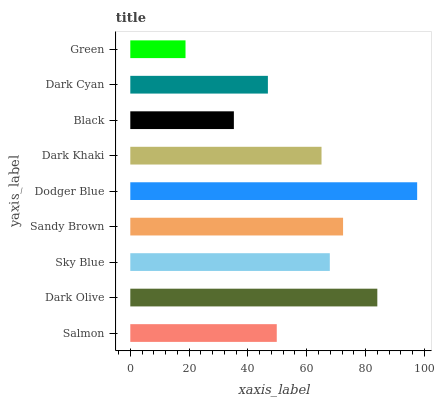Is Green the minimum?
Answer yes or no. Yes. Is Dodger Blue the maximum?
Answer yes or no. Yes. Is Dark Olive the minimum?
Answer yes or no. No. Is Dark Olive the maximum?
Answer yes or no. No. Is Dark Olive greater than Salmon?
Answer yes or no. Yes. Is Salmon less than Dark Olive?
Answer yes or no. Yes. Is Salmon greater than Dark Olive?
Answer yes or no. No. Is Dark Olive less than Salmon?
Answer yes or no. No. Is Dark Khaki the high median?
Answer yes or no. Yes. Is Dark Khaki the low median?
Answer yes or no. Yes. Is Dodger Blue the high median?
Answer yes or no. No. Is Salmon the low median?
Answer yes or no. No. 